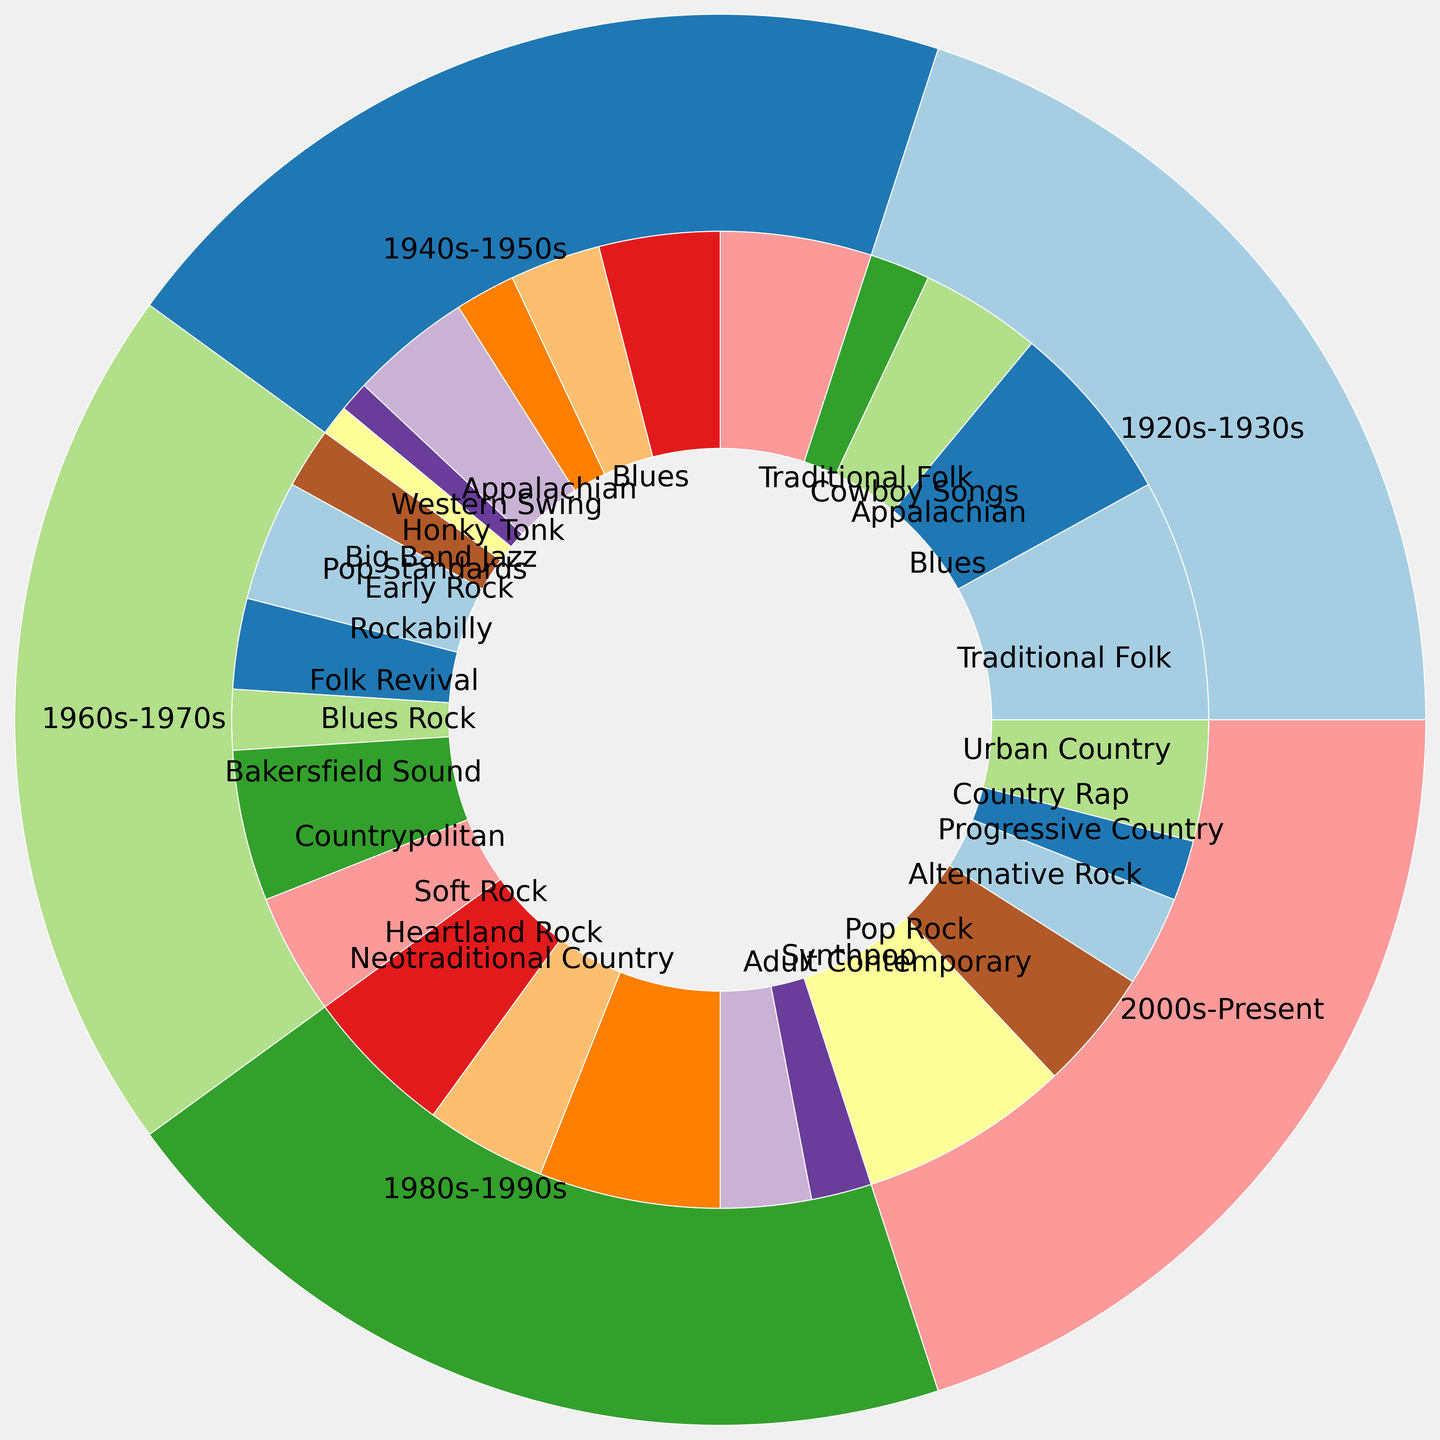What era had the highest overall influence on country music as depicted in the outer pie chart? Observe the outer pie chart section with the largest size. The 2000s-Present era has a significantly larger segment indicating the highest overall influence.
Answer: 2000s-Present How does the influence of Pop and Rock in the 1980s-1990s compare to that in the 2000s-Present? Compare the sizes of the inner pie segments for Pop and Rock in both epochs. In the 1980s-1990s, Pop and Rock contributed 45% (25% Soft Rock + 20% Heartland Rock), while in the 2000s-Present it's 55% (35% Pop Rock + 20% Alternative Rock). Thus, the influence increased.
Answer: Increased Which subcategory from the 1960s-1970s has the largest influence percentage? Look at the inner pie segments for the 1960s-1970s era and identify the subcategory with the largest size. The Bakersfield Sound has the largest influence with 25%.
Answer: Bakersfield Sound What is the combined influence percentage of Blues and Blues Rock across all eras? Sum the influences of Blues in 1920s-1930s (30%) and 1940s-1950s (20%) and Blues Rock in 1960s-1970s (10%). 30%+20%+10% = 60%.
Answer: 60% Which era shows the smallest influence from Jazz and Pop categories? Look for the era with the smallest segment for Jazz and Pop subcategories. The 1920s-1930s have no contribution from Jazz and Pop.
Answer: 1920s-1930s Compare the influence of Folk and Blues in the 1920s-1930s with that in the 1940s-1950s. Look at the inner pie segments and add up the subcategories under Folk and Blues. For 1920s-1930s, it's 40% (Traditional Folk) + 30% (Blues) = 70%. For 1940s-1950s, it's 25% (Traditional Folk) + 20% (Blues) = 45%.
Answer: Decreased What era introduced Country Rap and Urban Country subcategories, and what is their combined influence? Identify the segments labeled Country Rap (10%) and Urban Country (20%) and note their era (2000s-Present). Sum the influences: 10% + 20% = 30%.
Answer: 2000s-Present, 30% Which two subcategories in the 1980s-1990s era have equal influence? Inspect the inner pie chart sections for 1980s-1990s and find subcategories with equal segment sizes. Both Heartland Rock and Adult Contemporary have an influence of 20%.
Answer: Heartland Rock and Adult Contemporary What is the difference in influence between the two most significant American Roots subcategories in 1940s-1950s? The most significant subcategories are Honky Tonk (20%) and Appalachian (15%). The difference is 20% - 15% = 5%.
Answer: 5% Is the influence of Traditional Folk consistent across the 1920s-1930s and 1940s-1950s? Compare the Traditional Folk segments across the two eras. It is 40% in the 1920s-1930s and 25% in the 1940s-1950s. The influence decreased.
Answer: No, it decreased 